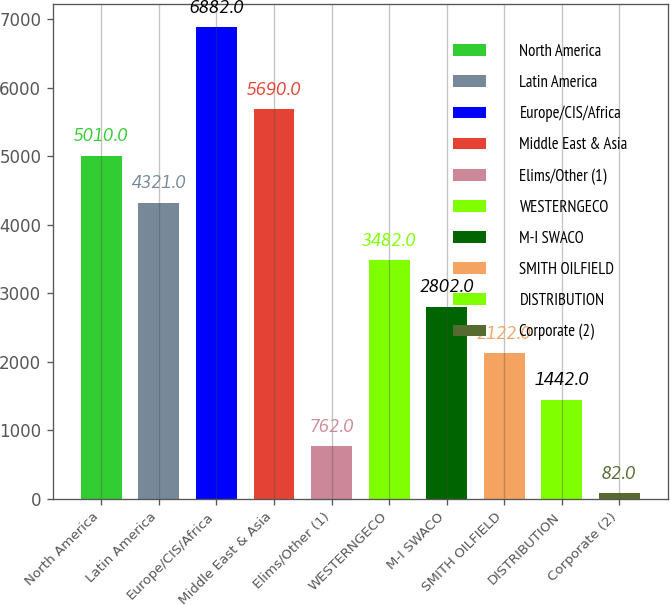Convert chart to OTSL. <chart><loc_0><loc_0><loc_500><loc_500><bar_chart><fcel>North America<fcel>Latin America<fcel>Europe/CIS/Africa<fcel>Middle East & Asia<fcel>Elims/Other (1)<fcel>WESTERNGECO<fcel>M-I SWACO<fcel>SMITH OILFIELD<fcel>DISTRIBUTION<fcel>Corporate (2)<nl><fcel>5010<fcel>4321<fcel>6882<fcel>5690<fcel>762<fcel>3482<fcel>2802<fcel>2122<fcel>1442<fcel>82<nl></chart> 